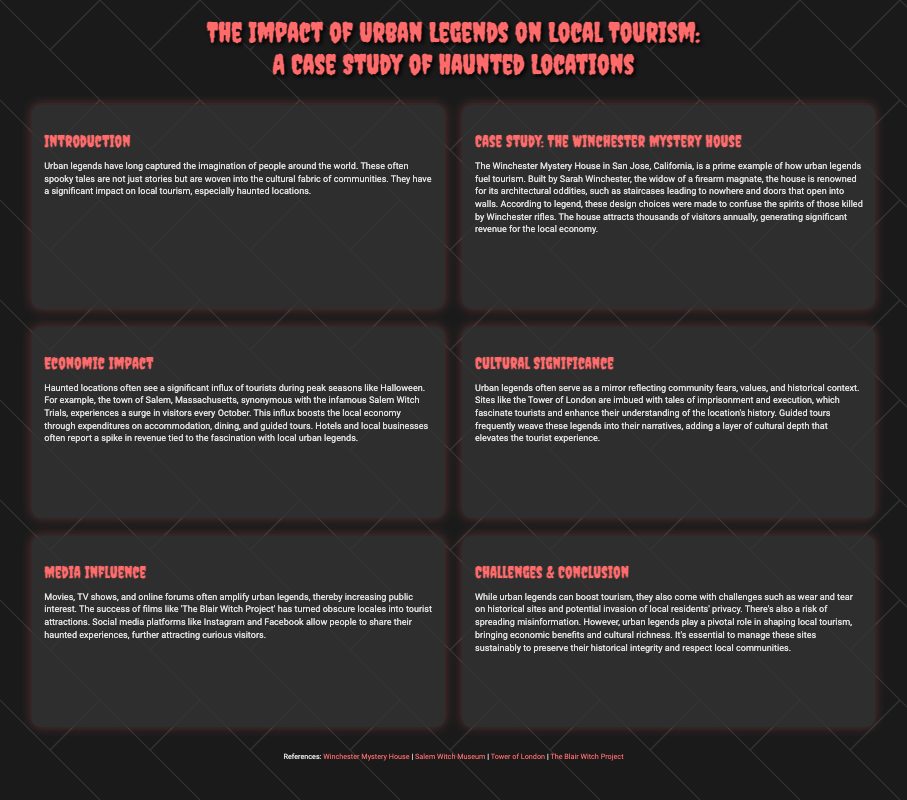What is the main topic of the poster? The title of the poster provides the primary focus, which is the cultural impact of urban legends on local tourism, specifically through haunted locations.
Answer: The impact of urban legends on local tourism Who is the builder of the Winchester Mystery House? The document mentions that Sarah Winchester is the builder of the Winchester Mystery House, connecting her to the urban legend surrounding the site.
Answer: Sarah Winchester What town is associated with the infamous Salem Witch Trials? The document states that Salem, Massachusetts is known for the Salem Witch Trials, highlighting its relevance to local urban legends and tourism.
Answer: Salem, Massachusetts How do haunted locations affect tourism during October? The document indicates that haunted locations experience a significant increase in tourist visitors during Halloween, showcasing the seasonal impact of urban legends.
Answer: Influx of tourists What does the Tower of London reflect about urban legends? According to the document, the Tower of London embodies community fears and historical context, enhancing tourists' understanding of its history through urban legends.
Answer: Community fears and historical context What challenge is mentioned regarding urban legends and tourism? The document lists several challenges, including the wear and tear on historical sites as a consequence of increased tourism driven by urban legends.
Answer: Wear and tear on historical sites Which film is mentioned as having increased public interest in haunted locations? The document references 'The Blair Witch Project' as a successful film that amplified interest in certain locations, turning them into tourist attractions.
Answer: The Blair Witch Project What economic activity does tourism boost in haunted locations? The document states that local economies benefit from expenditures on accommodation, dining, and guided tours, indicating specific activities that contribute to economic growth.
Answer: Accommodation, dining, and guided tours What is the conclusion about urban legends’ role in tourism? The document concludes that urban legends significantly shape local tourism while emphasizing the importance of sustainable management of these sites.
Answer: Significantly shape local tourism 